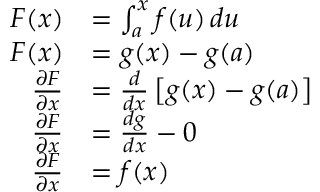Convert formula to latex. <formula><loc_0><loc_0><loc_500><loc_500>\begin{array} { r l } { F ( x ) } & { = \int _ { a } ^ { x } f ( u ) \, d u } \\ { F ( x ) } & { = g ( x ) - g ( a ) } \\ { \frac { \partial F } { \partial x } } & { = \frac { d } { d x } \left [ g ( x ) - g ( a ) \right ] } \\ { \frac { \partial F } { \partial x } } & { = \frac { d g } { d x } - 0 } \\ { \frac { \partial F } { \partial x } } & { = f ( x ) } \end{array}</formula> 